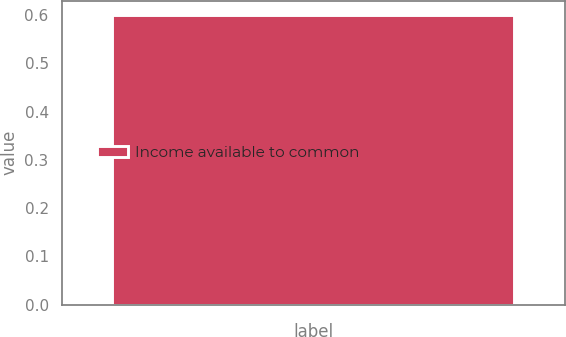Convert chart. <chart><loc_0><loc_0><loc_500><loc_500><bar_chart><fcel>Income available to common<nl><fcel>0.6<nl></chart> 